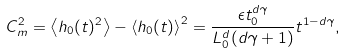<formula> <loc_0><loc_0><loc_500><loc_500>C _ { m } ^ { 2 } = \left < h _ { 0 } ( t ) ^ { 2 } \right > - \left < h _ { 0 } ( t ) \right > ^ { 2 } = \frac { \epsilon t _ { 0 } ^ { d \gamma } } { L _ { 0 } ^ { d } ( d \gamma + 1 ) } t ^ { 1 - d \gamma } ,</formula> 